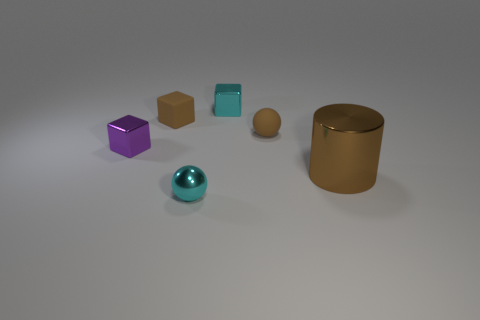Add 4 brown blocks. How many objects exist? 10 Subtract all cylinders. How many objects are left? 5 Add 6 large brown objects. How many large brown objects exist? 7 Subtract 0 green cylinders. How many objects are left? 6 Subtract all small cyan objects. Subtract all tiny cubes. How many objects are left? 1 Add 5 spheres. How many spheres are left? 7 